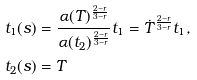Convert formula to latex. <formula><loc_0><loc_0><loc_500><loc_500>t _ { 1 } ( s ) & = \frac { \alpha ( T ) ^ { \frac { 2 - r } { 3 - r } } } { \alpha ( t _ { 2 } ) ^ { \frac { 2 - r } { 3 - r } } } t _ { 1 } = \dot { T } ^ { \frac { 2 - r } { 3 - r } } t _ { 1 } , \\ t _ { 2 } ( s ) & = T</formula> 